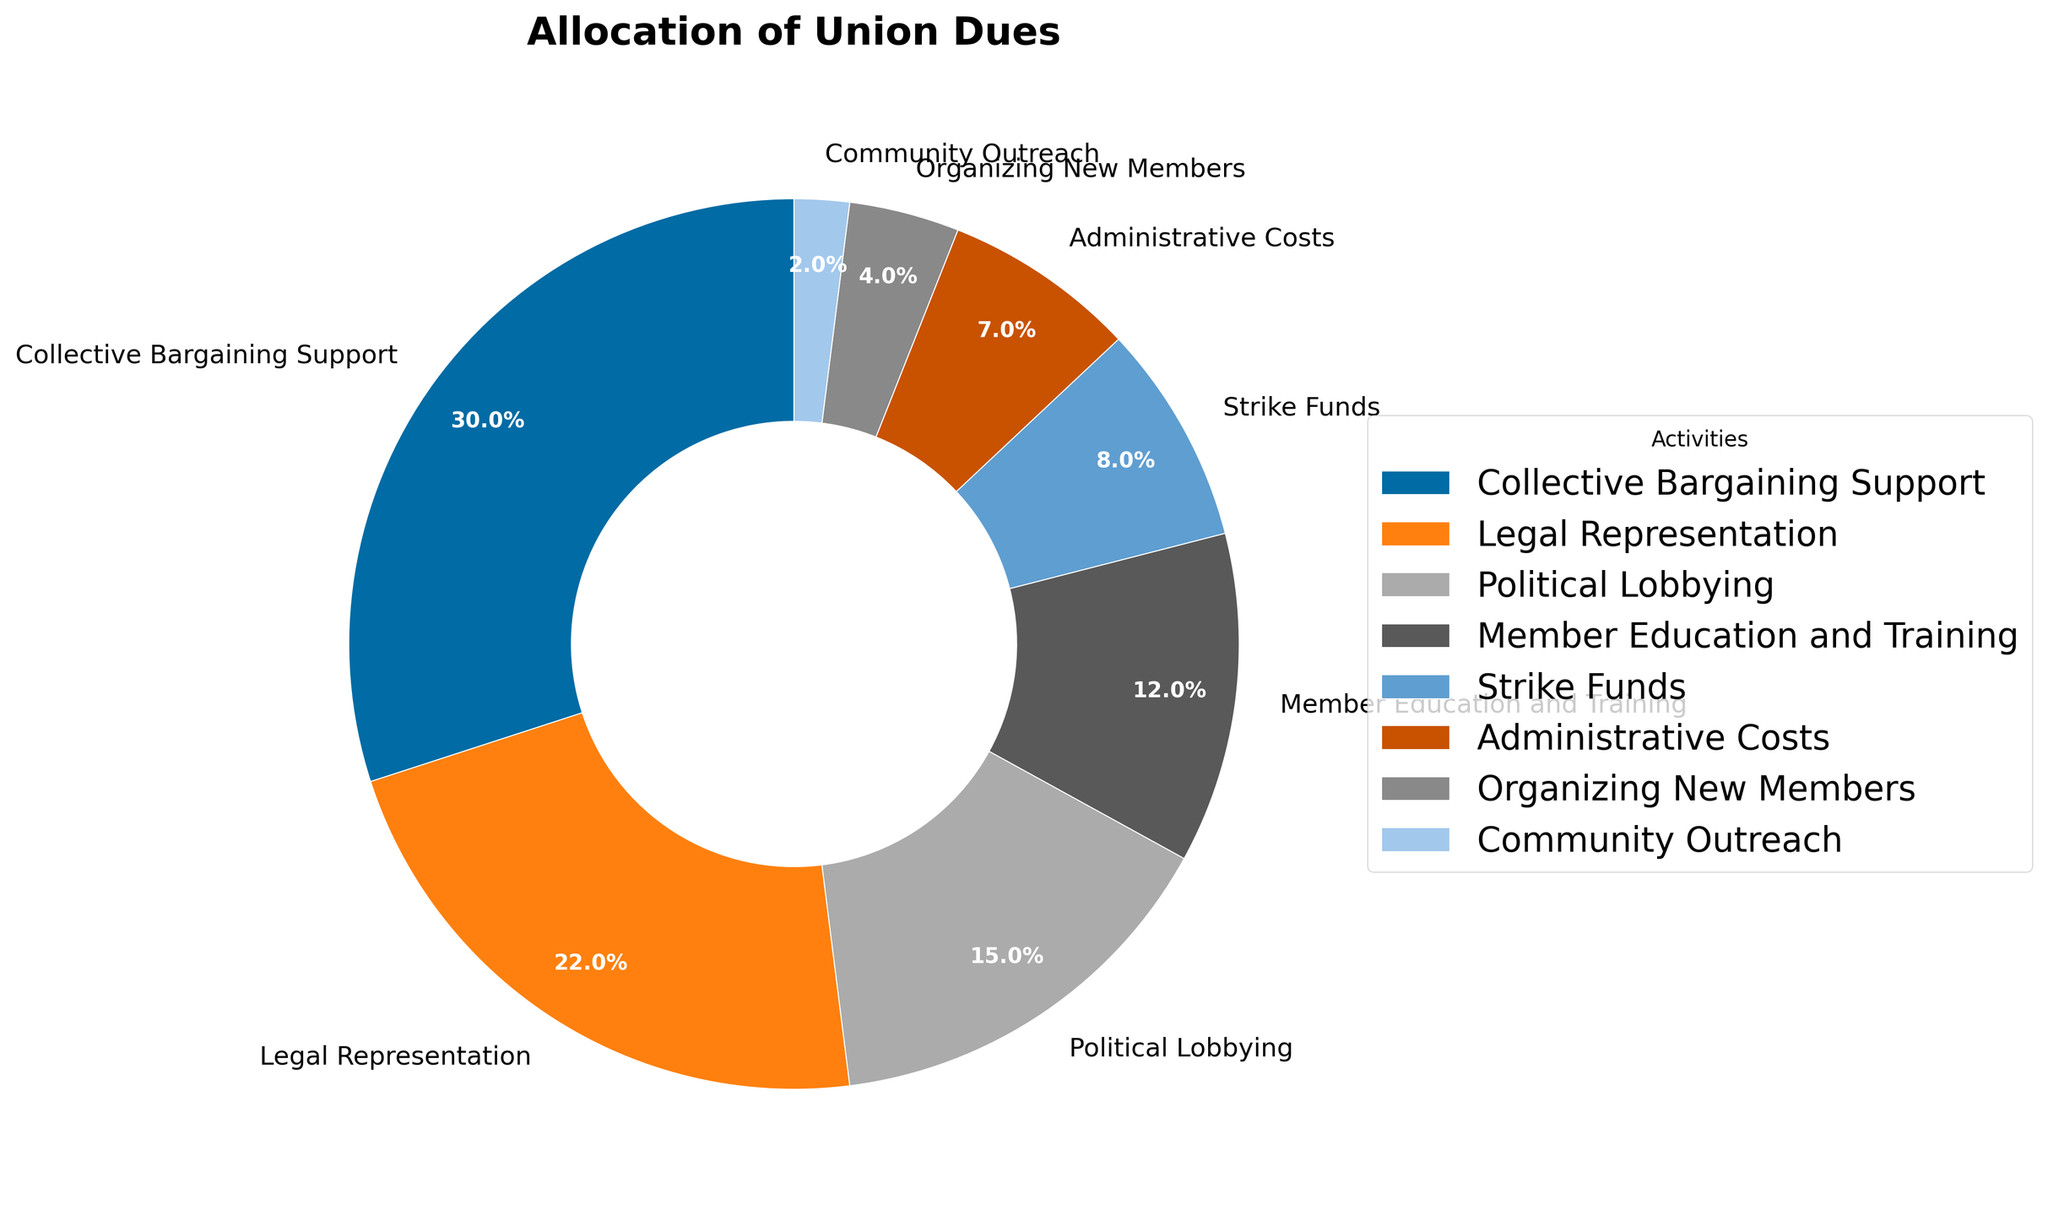What percentage of the union dues is allocated to Strike Funds and Organizing New Members combined? To find the combined percentage, add the individual percentages of both Strike Funds (8%) and Organizing New Members (4%). Thus, 8% + 4% = 12%.
Answer: 12% Which activity receives the largest allocation of union dues? Look at the chart and identify the activity with the largest percentage. Collective Bargaining Support is the largest, allocated 30% of the union dues.
Answer: Collective Bargaining Support Is the percentage of union dues allocated to Legal Representation greater than that for Member Education and Training? Compare the percentages of Legal Representation (22%) and Member Education and Training (12%). 22% is greater than 12%.
Answer: Yes What is the difference in union dues allocation between Collective Bargaining Support and Administrative Costs? Subtract the percentage for Administrative Costs (7%) from that of Collective Bargaining Support (30%). Thus, 30% - 7% = 23%.
Answer: 23% Which activities have allocations that are less than 10% of the total union dues? Identify the activities with percentages less than 10%. They are Strike Funds (8%), Administrative Costs (7%), Organizing New Members (4%), and Community Outreach (2%).
Answer: Strike Funds, Administrative Costs, Organizing New Members, Community Outreach What is the average percentage of union dues distribution for Political Lobbying, Member Education and Training, and Strike Funds? Add the percentages of the three activities (15% + 12% + 8%) and divide by the number of activities (3). So, (15% + 12% + 8%) / 3 = 35% / 3 ≈ 11.7%.
Answer: 11.7% Which allocated activity has the smallest slice in the pie chart? Look for the smallest percentage in the pie chart. Community Outreach has the smallest allocation with 2%.
Answer: Community Outreach Are the union dues allocated to Legal Representation and Political Lobbying equal when combined with Administrative Costs? Add Legal Representation (22%) and Political Lobbying (15%), then compare with Administrative Costs (7%). 22% + 15% = 37%, which is not equal to 7%.
Answer: No How does the allocation for Member Education and Training compare visually to that for Strike Funds? Observe the visual size of the slices for both activities; Member Education and Training (12%) is larger than Strike Funds (8%).
Answer: Member Education and Training is larger 